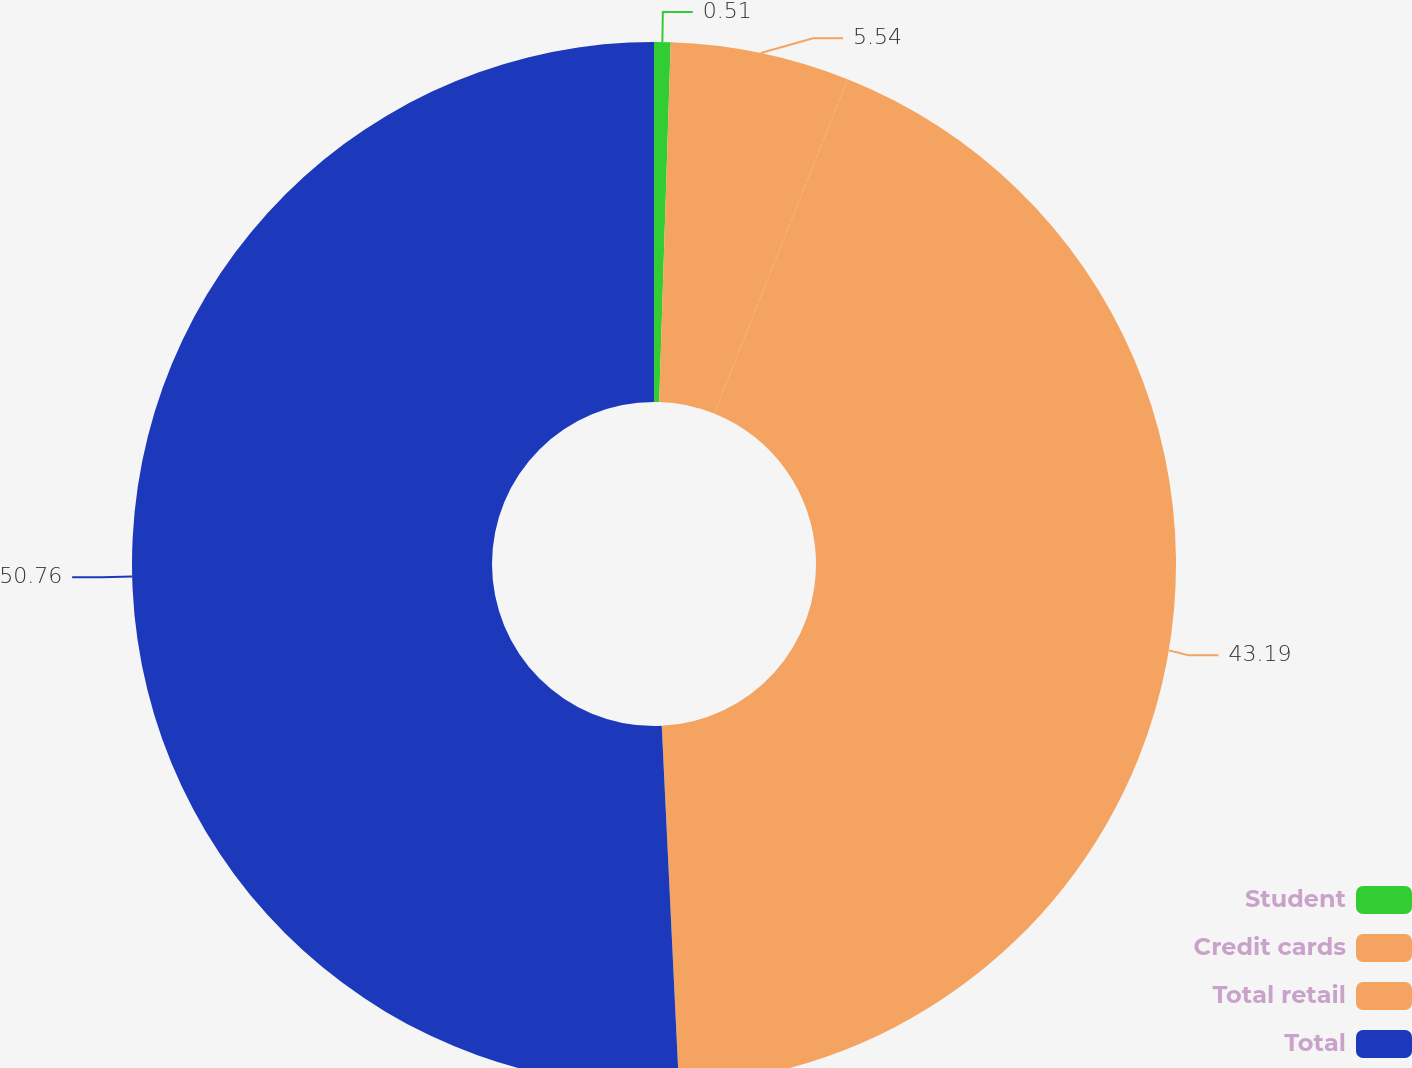Convert chart. <chart><loc_0><loc_0><loc_500><loc_500><pie_chart><fcel>Student<fcel>Credit cards<fcel>Total retail<fcel>Total<nl><fcel>0.51%<fcel>5.54%<fcel>43.19%<fcel>50.76%<nl></chart> 